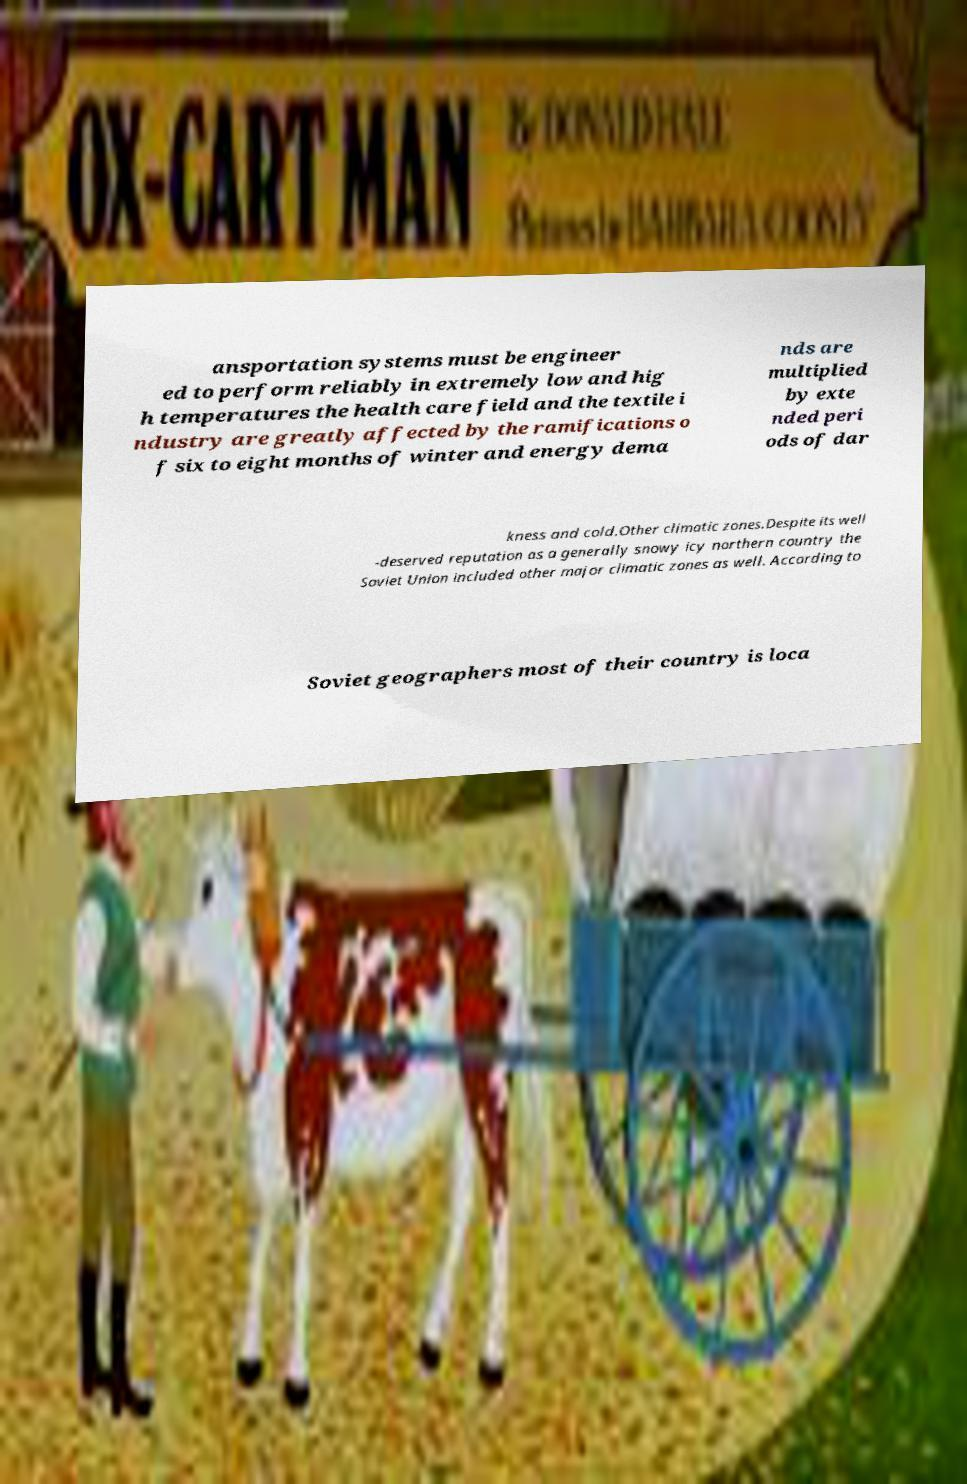Could you assist in decoding the text presented in this image and type it out clearly? ansportation systems must be engineer ed to perform reliably in extremely low and hig h temperatures the health care field and the textile i ndustry are greatly affected by the ramifications o f six to eight months of winter and energy dema nds are multiplied by exte nded peri ods of dar kness and cold.Other climatic zones.Despite its well -deserved reputation as a generally snowy icy northern country the Soviet Union included other major climatic zones as well. According to Soviet geographers most of their country is loca 